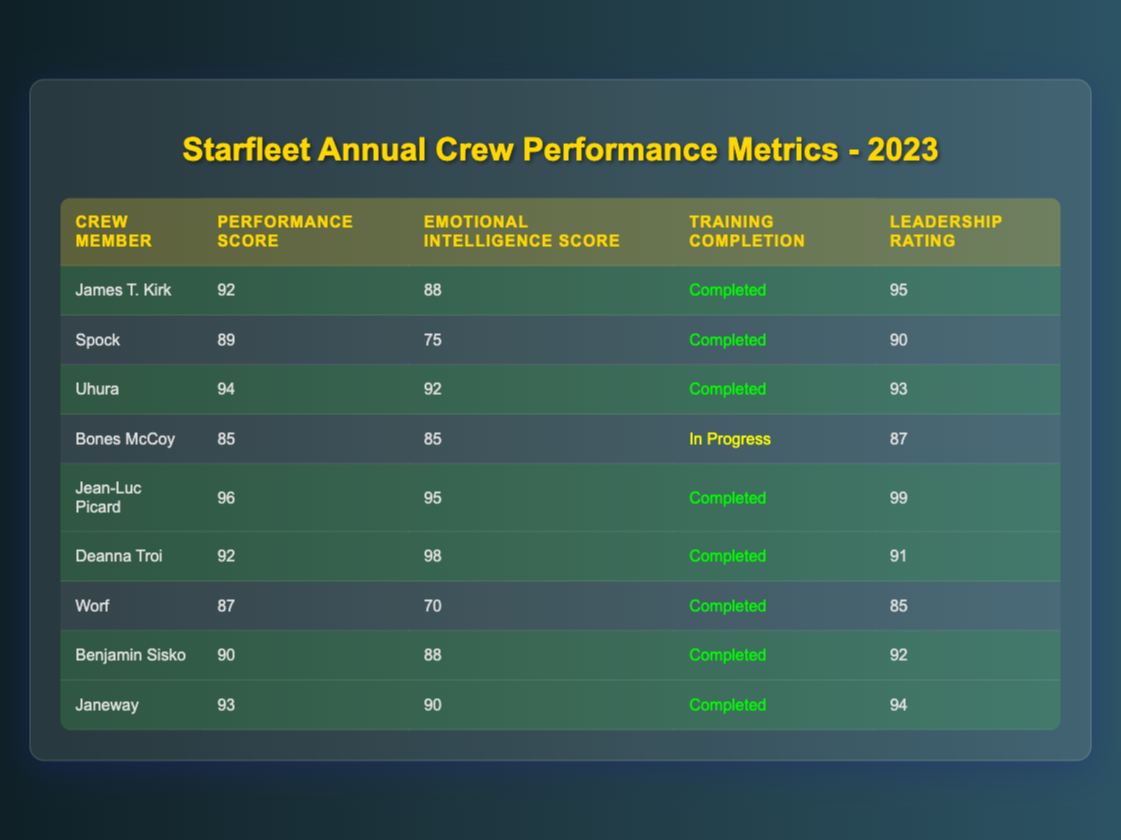What is the highest Performance Score in the table? The Performance Scores listed for each crew member are as follows: 92 (Kirk), 89 (Spock), 94 (Uhura), 85 (Bones McCoy), 96 (Picard), 92 (Deanna Troi), 87 (Worf), 90 (Sisko), and 93 (Janeway). The highest value is 96, which belongs to Jean-Luc Picard.
Answer: 96 Which crew member has the lowest Emotional Intelligence Score? The Emotional Intelligence Scores are as follows: 88 (Kirk), 75 (Spock), 92 (Uhura), 85 (Bones McCoy), 95 (Picard), 98 (Deanna Troi), 70 (Worf), 88 (Sisko), and 90 (Janeway). The lowest value is 70, which belongs to Worf.
Answer: Worf How many crew members completed the Emotional Intelligence Training? Reviewing the 'Training Completion' column, we see that six crew members (Kirk, Spock, Uhura, Picard, Troi, Sisko, and Janeway) marked "Completed." Bones McCoy's status is "In Progress," so it does not count.
Answer: 7 What is the average Leadership Rating of crew members who completed the Emotional Intelligence Training? The Leadership Ratings for those who completed training are: 95 (Kirk), 90 (Spock), 93 (Uhura), 99 (Picard), 91 (Troi), 92 (Sisko), and 94 (Janeway). Summing them gives 95 + 90 + 93 + 99 + 91 + 92 + 94 = 694. There are 7 crew members, so the average is 694 / 7 = 99.14.
Answer: 99.14 Is the Statement "Spock has a higher Emotional Intelligence Score than Worf" true? Comparing the Emotional Intelligence Scores, Spock's score is 75 and Worf's score is 70. Since 75 is greater than 70, the statement is true.
Answer: Yes Which crew member shows the best combination of high Performance Score and Emotional Intelligence Score? The top crew members by Performance and Emotional Intelligence Scores are: Kirk (92, 88), Uhura (94, 92), Picard (96, 95), Troi (92, 98), and Janeway (93, 90). The best combination based on scores suggests Picard with the highest Performance Score of 96 and a high Emotional Intelligence Score of 95.
Answer: Jean-Luc Picard How much higher is Janeway’s Performance Score compared to Bones McCoy’s? Janeway's Performance Score is 93, while Bones McCoy's score is 85. To find the difference: 93 - 85 = 8.
Answer: 8 What percentage of crew members has a Leadership Rating over 90? The Leadership Ratings above 90 are: Kirk (95), Picard (99), Troi (91), Sisko (92), and Janeway (94), totaling five crew members. There are nine crew members in total. Thus, the percentage is (5 / 9) * 100 = 55.56%.
Answer: 55.56% 